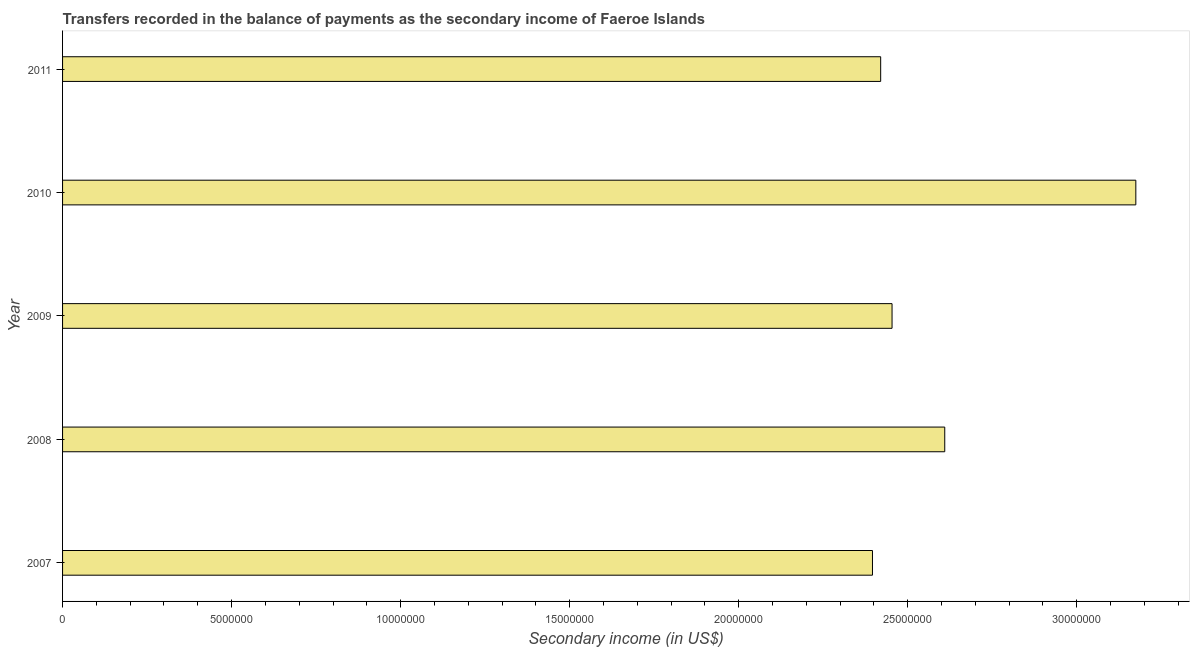What is the title of the graph?
Your answer should be very brief. Transfers recorded in the balance of payments as the secondary income of Faeroe Islands. What is the label or title of the X-axis?
Keep it short and to the point. Secondary income (in US$). What is the label or title of the Y-axis?
Provide a succinct answer. Year. What is the amount of secondary income in 2008?
Ensure brevity in your answer.  2.61e+07. Across all years, what is the maximum amount of secondary income?
Your answer should be compact. 3.17e+07. Across all years, what is the minimum amount of secondary income?
Your response must be concise. 2.40e+07. What is the sum of the amount of secondary income?
Offer a very short reply. 1.31e+08. What is the difference between the amount of secondary income in 2007 and 2011?
Give a very brief answer. -2.42e+05. What is the average amount of secondary income per year?
Ensure brevity in your answer.  2.61e+07. What is the median amount of secondary income?
Give a very brief answer. 2.45e+07. What is the ratio of the amount of secondary income in 2008 to that in 2011?
Offer a terse response. 1.08. Is the amount of secondary income in 2008 less than that in 2009?
Make the answer very short. No. Is the difference between the amount of secondary income in 2008 and 2010 greater than the difference between any two years?
Provide a short and direct response. No. What is the difference between the highest and the second highest amount of secondary income?
Offer a very short reply. 5.65e+06. Is the sum of the amount of secondary income in 2009 and 2010 greater than the maximum amount of secondary income across all years?
Provide a short and direct response. Yes. What is the difference between the highest and the lowest amount of secondary income?
Offer a very short reply. 7.79e+06. How many bars are there?
Ensure brevity in your answer.  5. Are all the bars in the graph horizontal?
Keep it short and to the point. Yes. What is the difference between two consecutive major ticks on the X-axis?
Provide a succinct answer. 5.00e+06. Are the values on the major ticks of X-axis written in scientific E-notation?
Offer a very short reply. No. What is the Secondary income (in US$) in 2007?
Your answer should be very brief. 2.40e+07. What is the Secondary income (in US$) in 2008?
Keep it short and to the point. 2.61e+07. What is the Secondary income (in US$) of 2009?
Provide a short and direct response. 2.45e+07. What is the Secondary income (in US$) in 2010?
Give a very brief answer. 3.17e+07. What is the Secondary income (in US$) of 2011?
Offer a terse response. 2.42e+07. What is the difference between the Secondary income (in US$) in 2007 and 2008?
Provide a short and direct response. -2.14e+06. What is the difference between the Secondary income (in US$) in 2007 and 2009?
Give a very brief answer. -5.79e+05. What is the difference between the Secondary income (in US$) in 2007 and 2010?
Ensure brevity in your answer.  -7.79e+06. What is the difference between the Secondary income (in US$) in 2007 and 2011?
Keep it short and to the point. -2.42e+05. What is the difference between the Secondary income (in US$) in 2008 and 2009?
Offer a very short reply. 1.56e+06. What is the difference between the Secondary income (in US$) in 2008 and 2010?
Your answer should be compact. -5.65e+06. What is the difference between the Secondary income (in US$) in 2008 and 2011?
Offer a terse response. 1.90e+06. What is the difference between the Secondary income (in US$) in 2009 and 2010?
Your answer should be compact. -7.21e+06. What is the difference between the Secondary income (in US$) in 2009 and 2011?
Ensure brevity in your answer.  3.37e+05. What is the difference between the Secondary income (in US$) in 2010 and 2011?
Offer a terse response. 7.55e+06. What is the ratio of the Secondary income (in US$) in 2007 to that in 2008?
Keep it short and to the point. 0.92. What is the ratio of the Secondary income (in US$) in 2007 to that in 2009?
Provide a short and direct response. 0.98. What is the ratio of the Secondary income (in US$) in 2007 to that in 2010?
Provide a short and direct response. 0.76. What is the ratio of the Secondary income (in US$) in 2007 to that in 2011?
Provide a short and direct response. 0.99. What is the ratio of the Secondary income (in US$) in 2008 to that in 2009?
Offer a terse response. 1.06. What is the ratio of the Secondary income (in US$) in 2008 to that in 2010?
Your response must be concise. 0.82. What is the ratio of the Secondary income (in US$) in 2008 to that in 2011?
Offer a terse response. 1.08. What is the ratio of the Secondary income (in US$) in 2009 to that in 2010?
Ensure brevity in your answer.  0.77. What is the ratio of the Secondary income (in US$) in 2009 to that in 2011?
Ensure brevity in your answer.  1.01. What is the ratio of the Secondary income (in US$) in 2010 to that in 2011?
Provide a short and direct response. 1.31. 